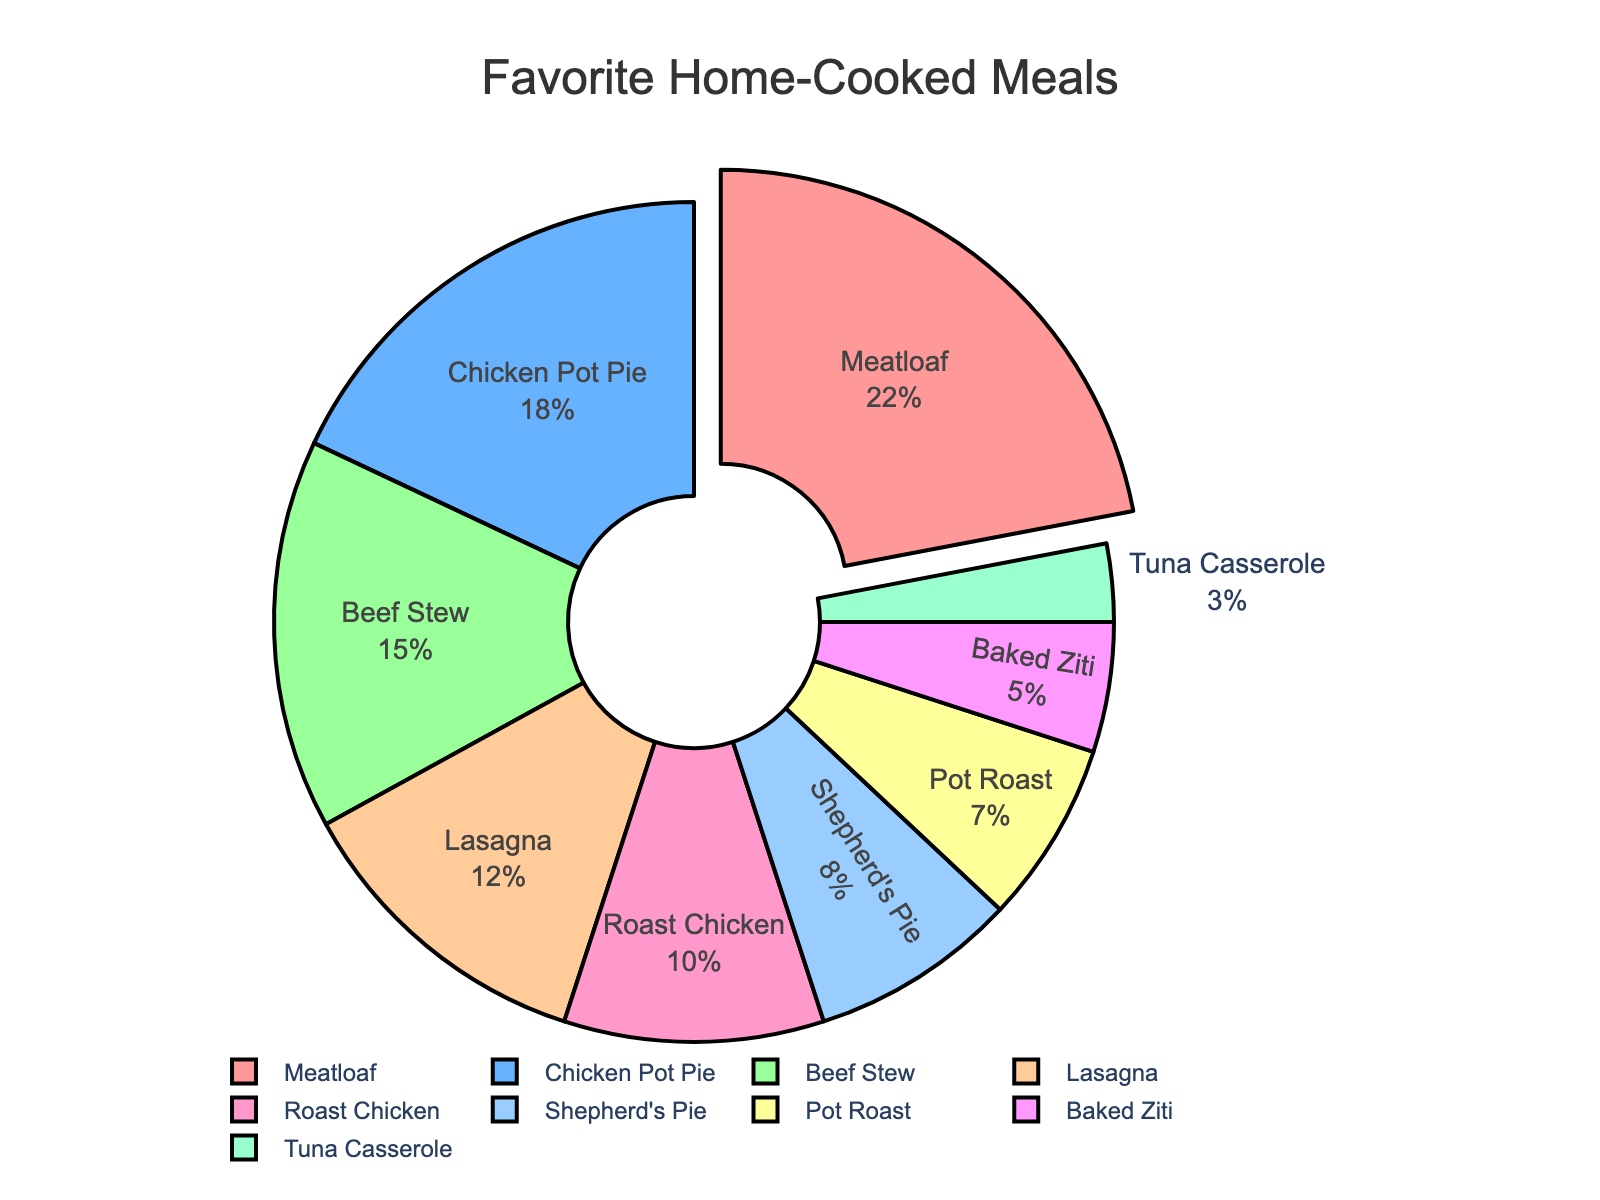What is the most popular home-cooked meal? The largest segment of the pie chart represents the meal with the highest percentage. The segment pulled out for emphasis is "Meatloaf" with 22%.
Answer: Meatloaf What percentage of people prefer Chicken Pot Pie over Lasagna? Subtract the percentage of people who prefer Lasagna from the percentage of those who prefer Chicken Pot Pie: 18% - 12% = 6%.
Answer: 6% What is the combined percentage of people who prefer Meatloaf, Chicken Pot Pie, and Beef Stew? Add the percentages for these meals: 22% (Meatloaf) + 18% (Chicken Pot Pie) + 15% (Beef Stew) = 55%.
Answer: 55% Which meal has a smaller percentage of preference than Pot Roast but higher than Tuna Casserole? The pie chart shows "Baked Ziti" with 5%, which fits between 7% (Pot Roast) and 3% (Tuna Casserole).
Answer: Baked Ziti How does the preference for Roast Chicken compare to that for Shepherd's Pie? The percentage for Roast Chicken is 10%, and for Shepherd's Pie, it's 8%. Roast Chicken has a 2% higher preference.
Answer: Roast Chicken is preferred 2% more than Shepherd's Pie How much more popular is Lasagna than Tuna Casserole? The percentage for Lasagna is 12%, and for Tuna Casserole, it's 3%. Subtract the smaller percentage from the larger: 12% - 3% = 9%.
Answer: 9% Which meal has the least preference, and what is its percentage? The smallest segment in the pie chart corresponds to "Tuna Casserole" with 3%.
Answer: Tuna Casserole, 3% What is the sum of the percentages for meals with chicken in their name? Add the percentages for Chicken Pot Pie (18%) and Roast Chicken (10%): 18% + 10% = 28%.
Answer: 28% What is the percent difference between the most preferred and least preferred meals? Subtract the percentage of the least preferred meal (Tuna Casserole, 3%) from the most preferred meal (Meatloaf, 22%): 22% - 3% = 19%.
Answer: 19% Which meal appears in green, and what is its percentage? The pie chart shows that "Beef Stew" is the segment colored green, corresponding to 15%.
Answer: Beef Stew, 15% 